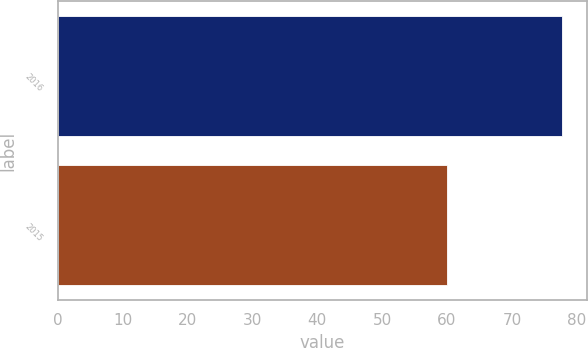<chart> <loc_0><loc_0><loc_500><loc_500><bar_chart><fcel>2016<fcel>2015<nl><fcel>77.71<fcel>60<nl></chart> 